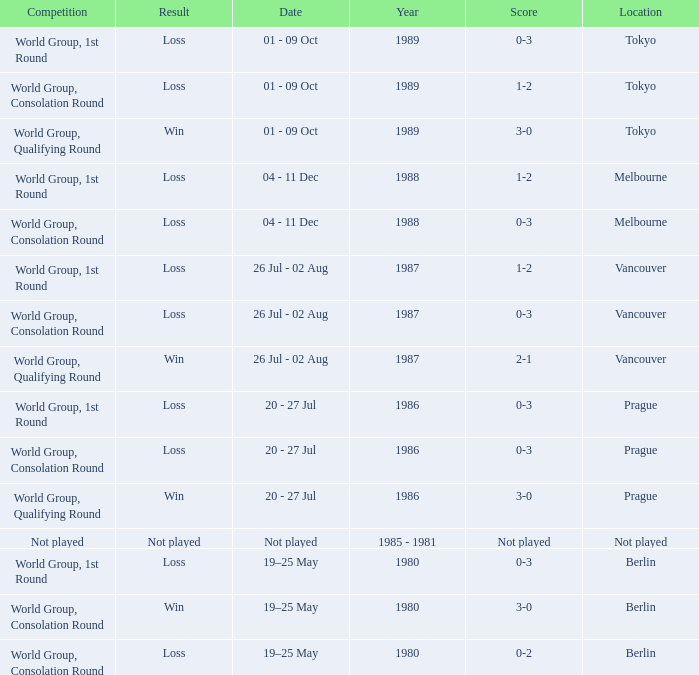What is the date for the game in prague for the world group, consolation round competition? 20 - 27 Jul. 